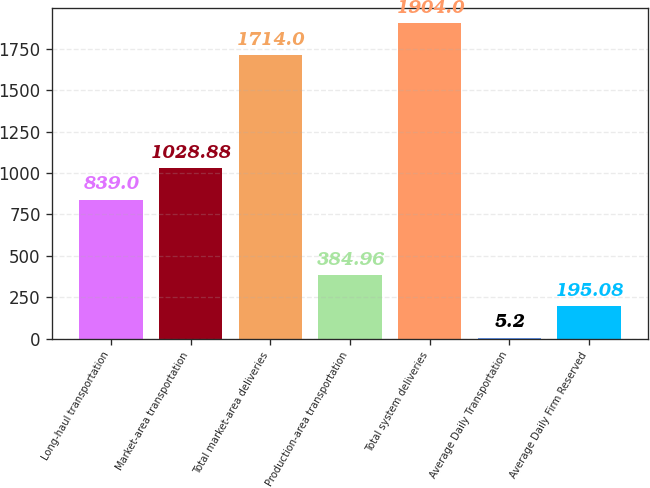Convert chart to OTSL. <chart><loc_0><loc_0><loc_500><loc_500><bar_chart><fcel>Long-haul transportation<fcel>Market-area transportation<fcel>Total market-area deliveries<fcel>Production-area transportation<fcel>Total system deliveries<fcel>Average Daily Transportation<fcel>Average Daily Firm Reserved<nl><fcel>839<fcel>1028.88<fcel>1714<fcel>384.96<fcel>1904<fcel>5.2<fcel>195.08<nl></chart> 